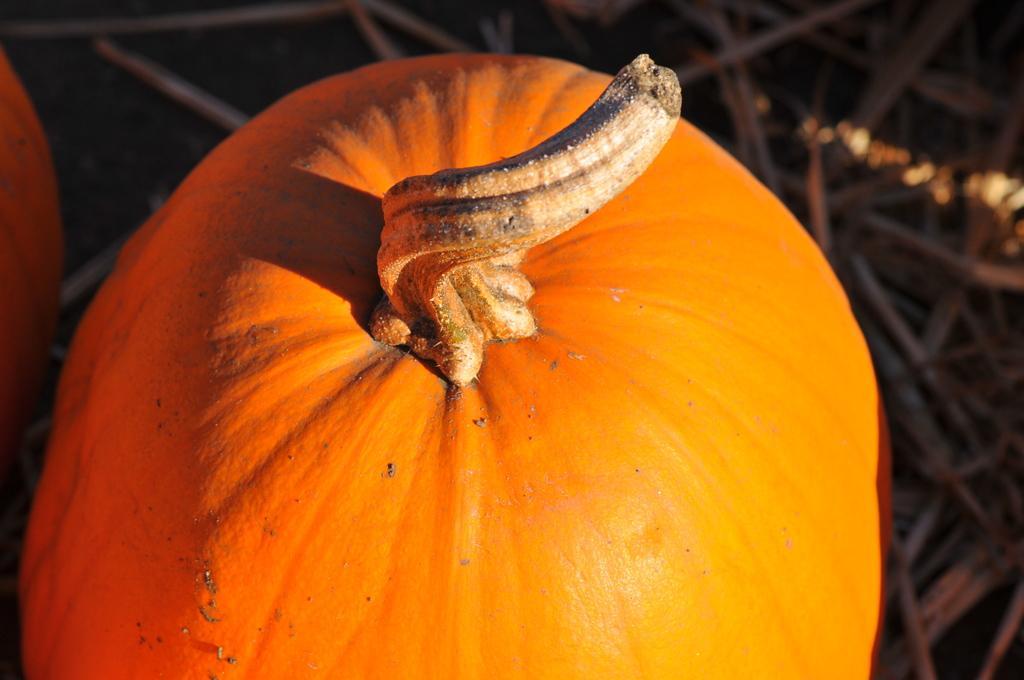What is the main object in the front of the image? There is a pumpkin in the front of the image. What can be seen in the background of the image? There are sticks visible in the background of the image. What type of ornament is hanging from the middle of the pumpkin in the image? There is no ornament hanging from the middle of the pumpkin in the image. 